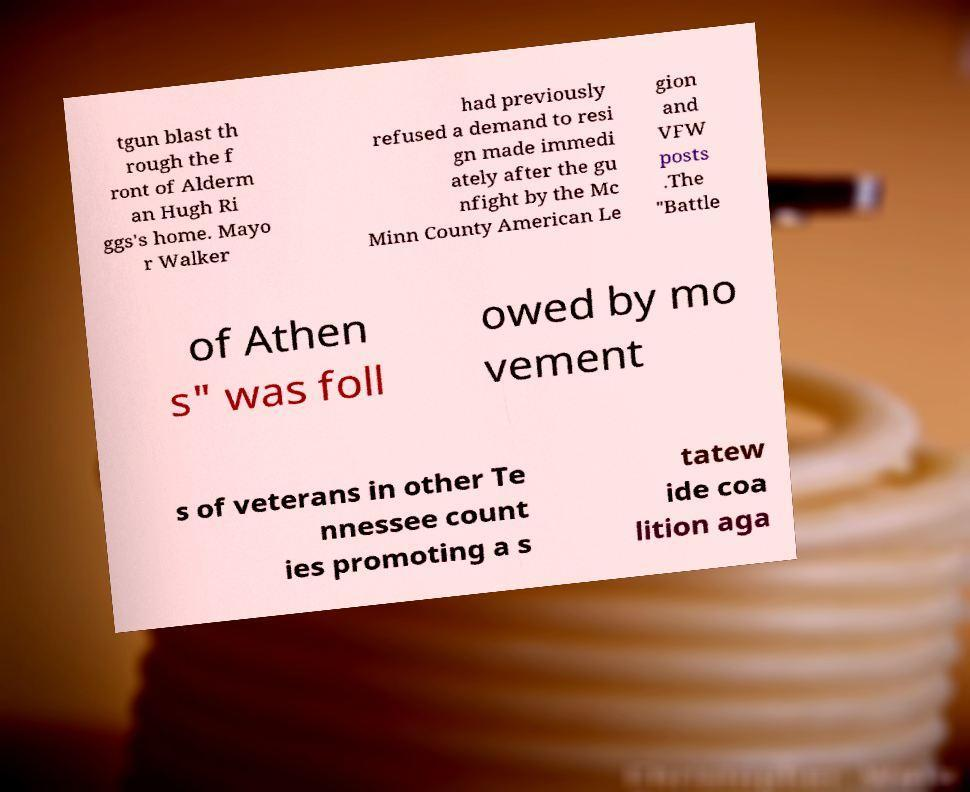There's text embedded in this image that I need extracted. Can you transcribe it verbatim? tgun blast th rough the f ront of Alderm an Hugh Ri ggs's home. Mayo r Walker had previously refused a demand to resi gn made immedi ately after the gu nfight by the Mc Minn County American Le gion and VFW posts .The "Battle of Athen s" was foll owed by mo vement s of veterans in other Te nnessee count ies promoting a s tatew ide coa lition aga 